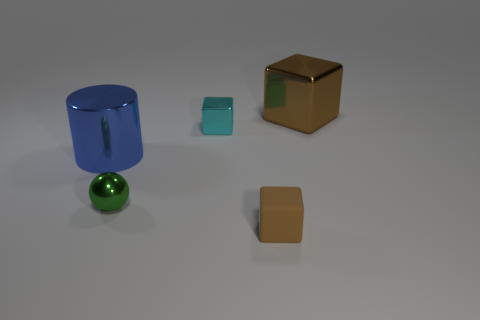Subtract all small brown rubber blocks. How many blocks are left? 2 Add 2 tiny purple shiny cylinders. How many objects exist? 7 Subtract 1 cubes. How many cubes are left? 2 Subtract all cyan blocks. How many blocks are left? 2 Subtract all cylinders. How many objects are left? 4 Subtract all gray cylinders. How many brown blocks are left? 2 Subtract all tiny blue objects. Subtract all green metallic spheres. How many objects are left? 4 Add 5 brown blocks. How many brown blocks are left? 7 Add 2 large brown blocks. How many large brown blocks exist? 3 Subtract 0 cyan cylinders. How many objects are left? 5 